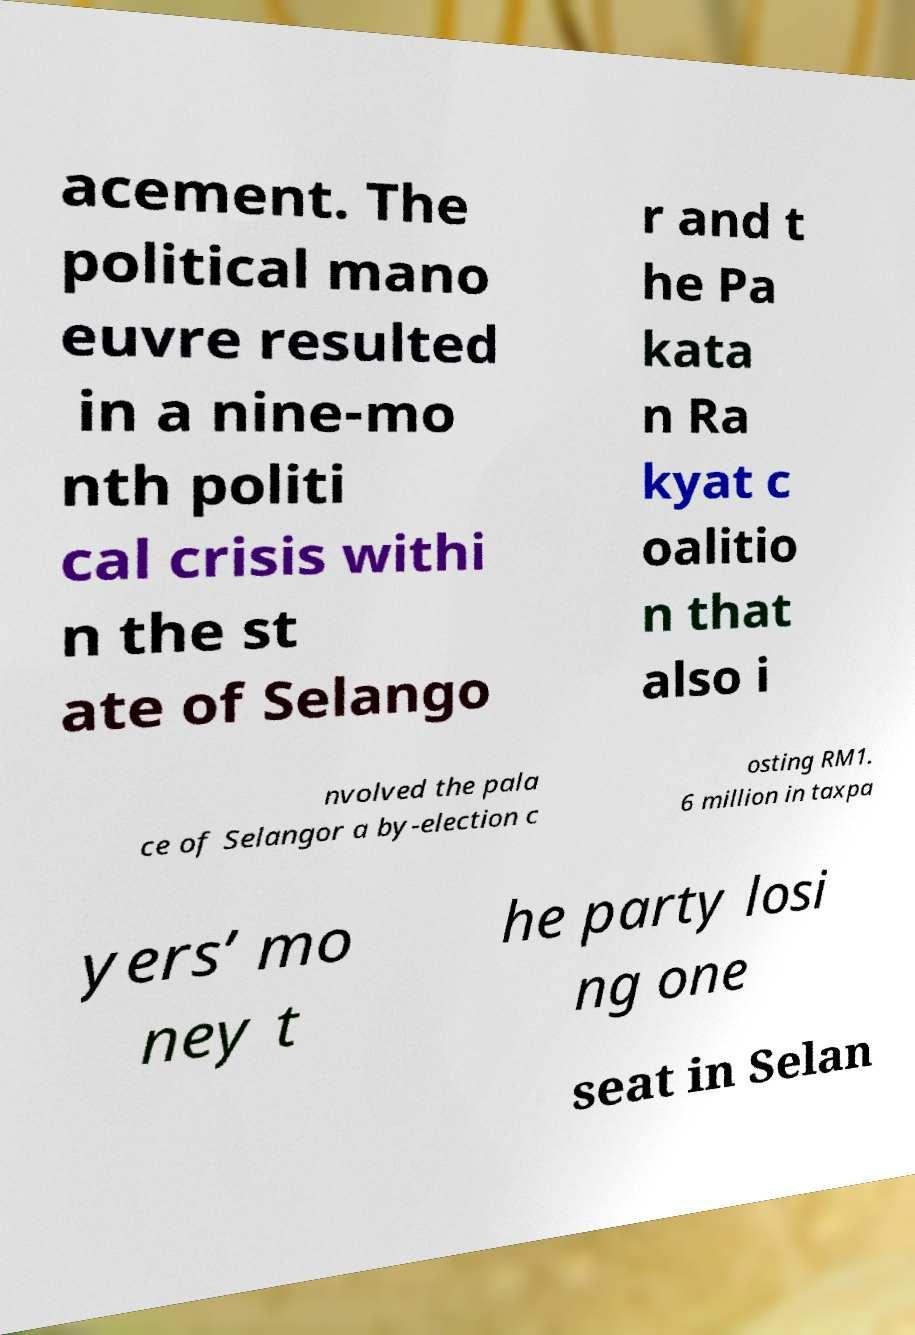For documentation purposes, I need the text within this image transcribed. Could you provide that? acement. The political mano euvre resulted in a nine-mo nth politi cal crisis withi n the st ate of Selango r and t he Pa kata n Ra kyat c oalitio n that also i nvolved the pala ce of Selangor a by-election c osting RM1. 6 million in taxpa yers’ mo ney t he party losi ng one seat in Selan 